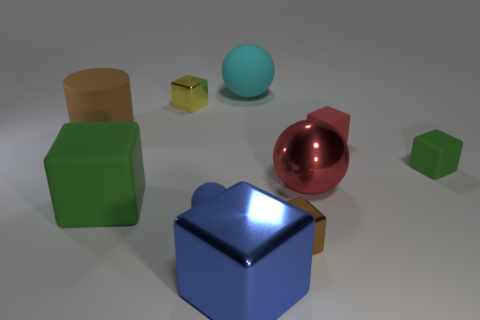How many tiny things are brown objects or rubber things?
Your response must be concise. 4. How big is the blue cube?
Provide a succinct answer. Large. There is a brown rubber object; what shape is it?
Keep it short and to the point. Cylinder. Are there any other things that have the same shape as the large cyan rubber thing?
Give a very brief answer. Yes. Are there fewer things that are right of the large matte block than large red spheres?
Your answer should be compact. No. There is a large block behind the small blue object; does it have the same color as the matte cylinder?
Your answer should be compact. No. How many matte objects are tiny brown objects or cubes?
Provide a short and direct response. 3. There is another small thing that is made of the same material as the small yellow thing; what color is it?
Your response must be concise. Brown. What number of blocks are either red metal objects or large objects?
Your response must be concise. 2. How many things are big red matte spheres or red shiny balls that are to the left of the tiny green matte cube?
Your response must be concise. 1. 